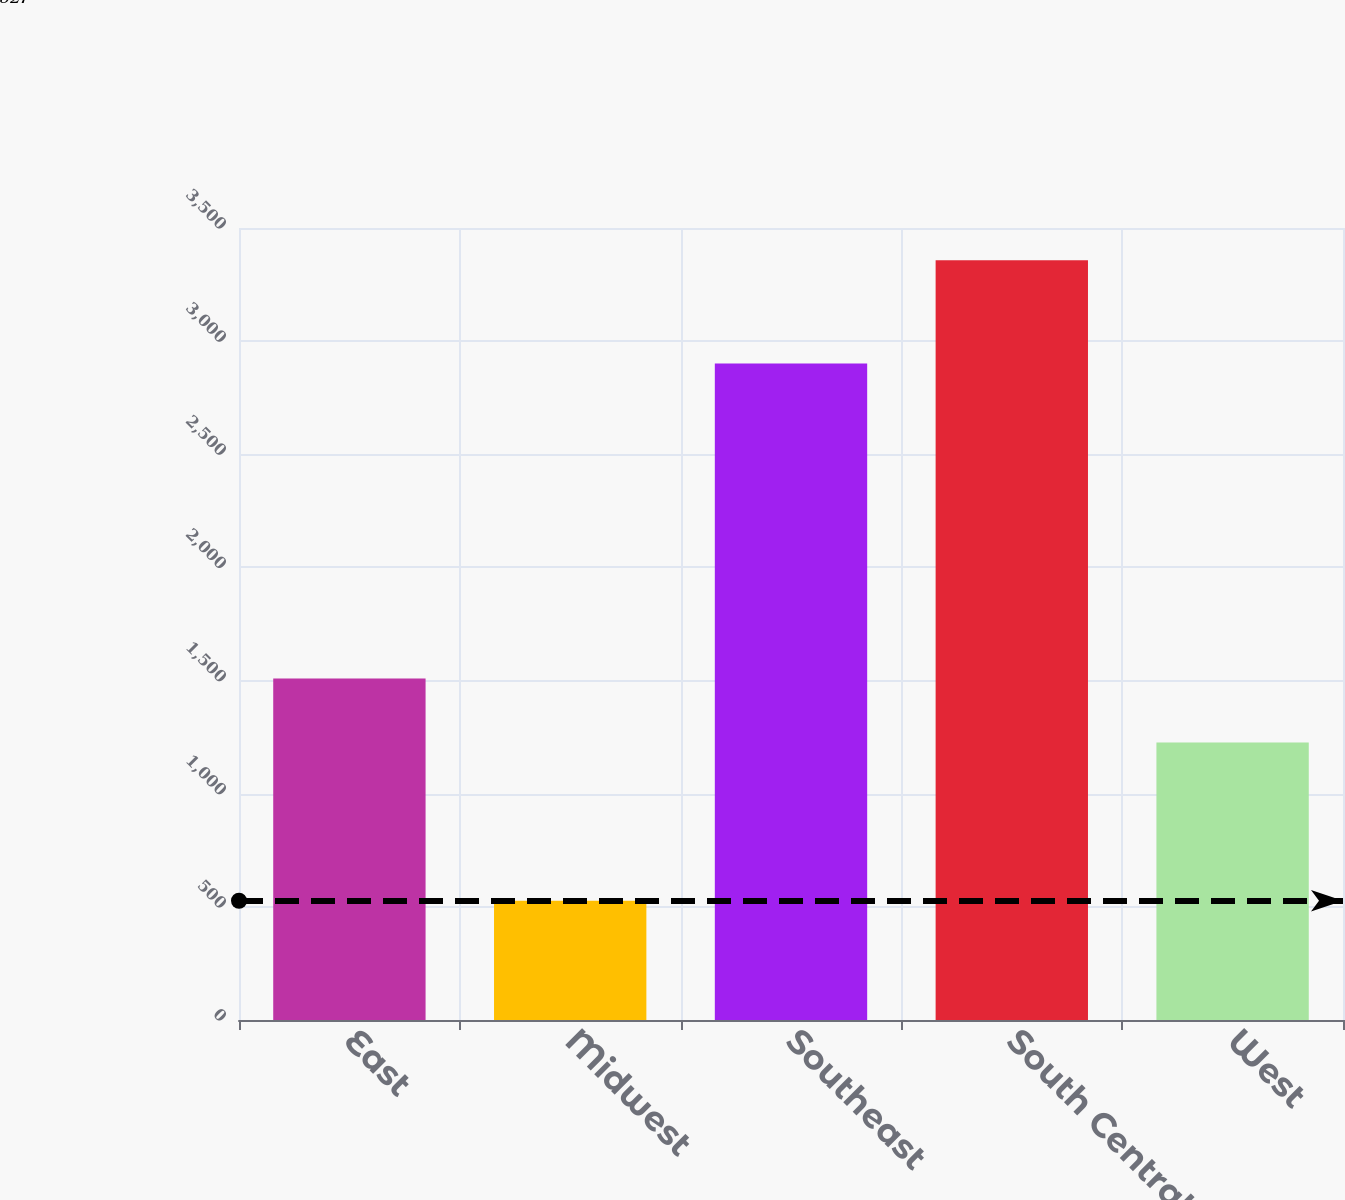Convert chart to OTSL. <chart><loc_0><loc_0><loc_500><loc_500><bar_chart><fcel>East<fcel>Midwest<fcel>Southeast<fcel>South Central<fcel>West<nl><fcel>1509.1<fcel>527<fcel>2901<fcel>3358<fcel>1226<nl></chart> 